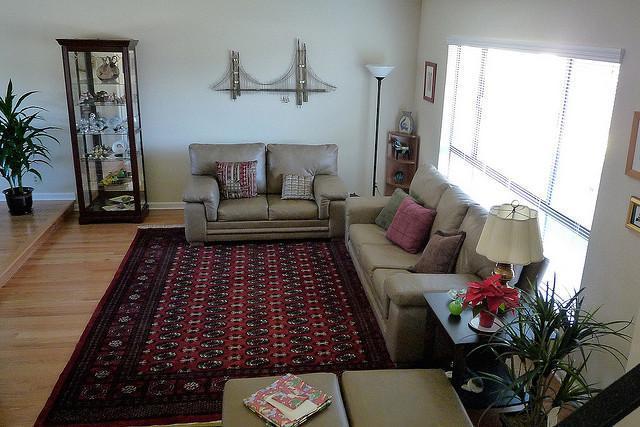How many shelves in the curio cabinet?
Give a very brief answer. 5. How many different vases are there?
Give a very brief answer. 2. How many pillows are on the two couches?
Give a very brief answer. 5. How many rugs on there?
Give a very brief answer. 1. How many potted plants can be seen?
Give a very brief answer. 2. How many couches are there?
Give a very brief answer. 2. How many dining tables are there?
Give a very brief answer. 1. 